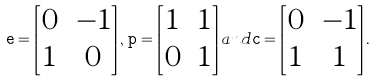Convert formula to latex. <formula><loc_0><loc_0><loc_500><loc_500>{ \tt e } = \begin{bmatrix} 0 & - 1 \\ 1 & 0 \end{bmatrix} , \, { \tt p } = \begin{bmatrix} 1 & 1 \\ 0 & 1 \end{bmatrix} a n d { \tt c } = \begin{bmatrix} 0 & - 1 \\ 1 & 1 \end{bmatrix} .</formula> 